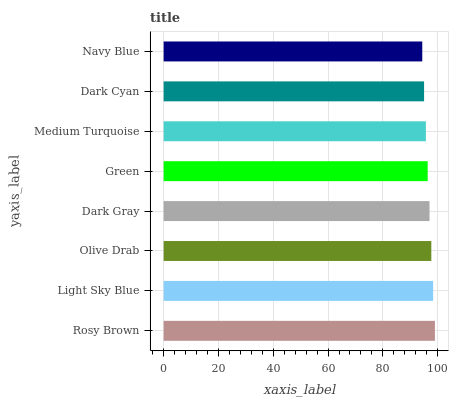Is Navy Blue the minimum?
Answer yes or no. Yes. Is Rosy Brown the maximum?
Answer yes or no. Yes. Is Light Sky Blue the minimum?
Answer yes or no. No. Is Light Sky Blue the maximum?
Answer yes or no. No. Is Rosy Brown greater than Light Sky Blue?
Answer yes or no. Yes. Is Light Sky Blue less than Rosy Brown?
Answer yes or no. Yes. Is Light Sky Blue greater than Rosy Brown?
Answer yes or no. No. Is Rosy Brown less than Light Sky Blue?
Answer yes or no. No. Is Dark Gray the high median?
Answer yes or no. Yes. Is Green the low median?
Answer yes or no. Yes. Is Dark Cyan the high median?
Answer yes or no. No. Is Dark Gray the low median?
Answer yes or no. No. 